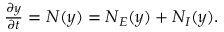Convert formula to latex. <formula><loc_0><loc_0><loc_500><loc_500>\begin{array} { r } { \frac { \partial y } { \partial t } = N ( y ) = N _ { E } ( y ) + N _ { I } ( y ) . } \end{array}</formula> 